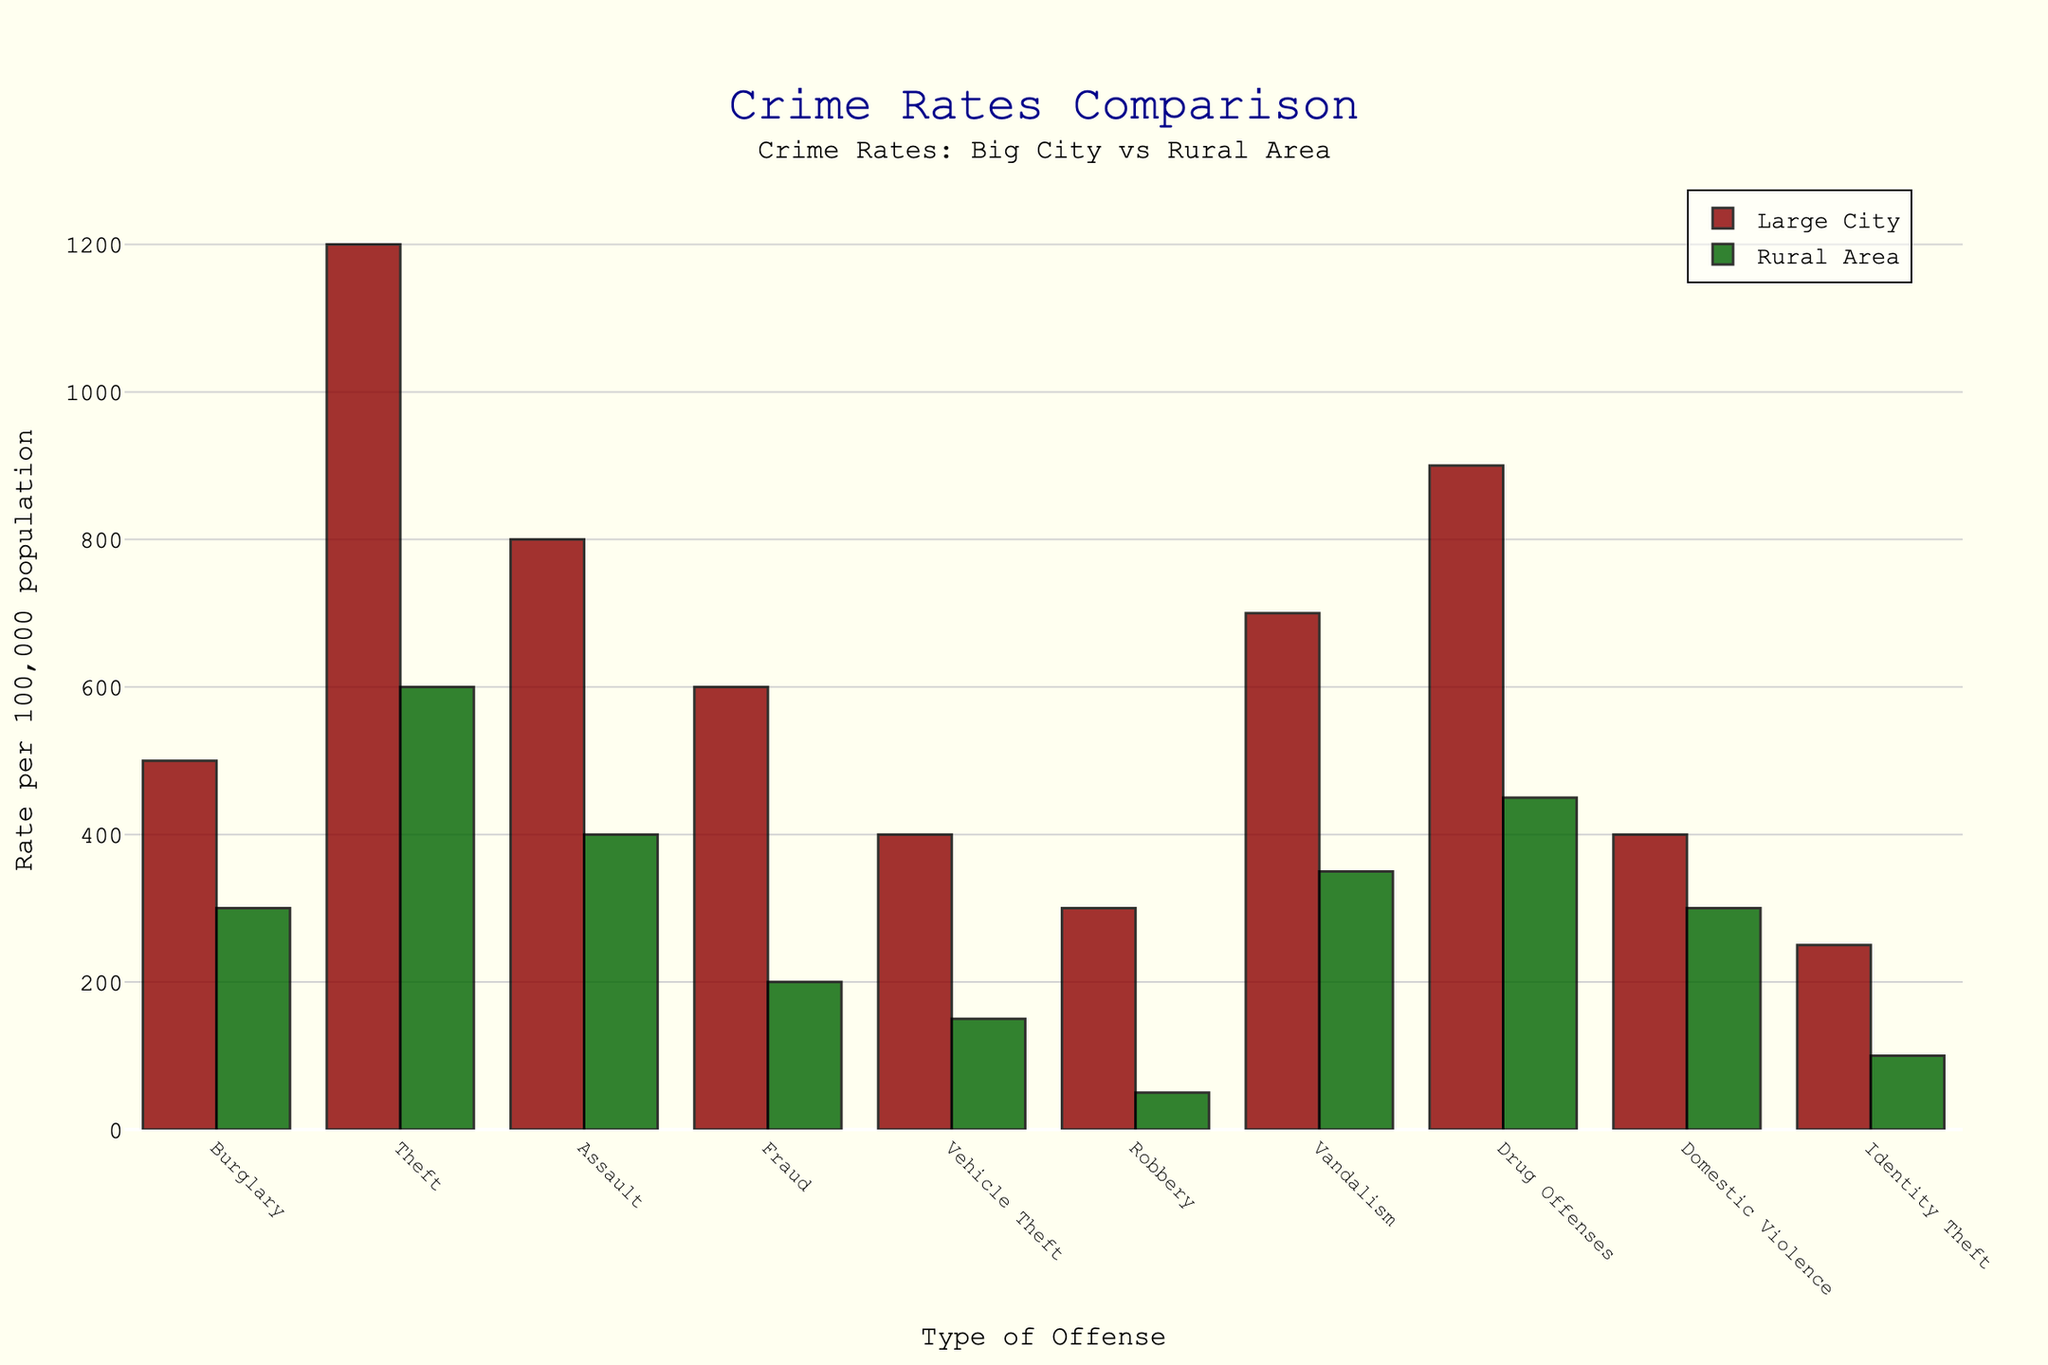What's the difference in burglary rates between large cities and rural areas? The burglary rate in large cities is 500 per 100k, while in rural areas it is 300 per 100k. To find the difference, subtract the rural rate from the large city rate: 500 - 300 = 200.
Answer: 200 Which type of offense has the highest rate in rural areas? By looking at the bars for rural areas, the highest point is for 'Theft' which is 600 per 100k.
Answer: Theft Are there any offenses where the rate is the same in both large cities and rural areas? Scanning the heights of the bars for both large cities and rural areas, we see that 'Domestic Violence' has the same rate, both at 400 per 100k.
Answer: Domestic Violence Do large cities always have higher crime rates than rural areas? From the bars, we can see that large cities have higher rates for all offenses listed.
Answer: Yes What's the average rate of fraud and identity theft in large cities? The fraud rate in large cities is 600 per 100k, and the identity theft rate is 250 per 100k. The average is calculated as (600 + 250)/2 = 425.
Answer: 425 Which areas have a higher rate for drug offenses, and by how much? For drug offenses, large cities have a rate of 900 per 100k, while rural areas have 450 per 100k. The difference is 900 - 450 = 450.
Answer: Large cities, 450 In terms of visual height of the bars, which offense stands out the most in large cities? By observing the tallest bar for large cities, 'Theft' stands out the most with a height representing 1200 per 100k.
Answer: Theft Between large cities and rural areas, which has a lower rate for vandalism by how much? The rate for vandalism in large cities is 700 per 100k, while in rural areas it's 350 per 100k. The difference is 700 - 350 = 350.
Answer: Rural areas, 350 Which offense is specifically notable for its much lower rate in rural areas compared to large cities? 'Robbery' has a significant visual discrepancy with large cities at 300 per 100k and rural areas at 50 per 100k. The difference is 300 - 50 = 250.
Answer: Robbery What is the total combined rate for all offenses in rural areas? Sum all the rural area rates: 300 + 600 + 400 + 200 + 150 + 50 + 350 + 450 + 300 + 100 = 2900 per 100k.
Answer: 2900 